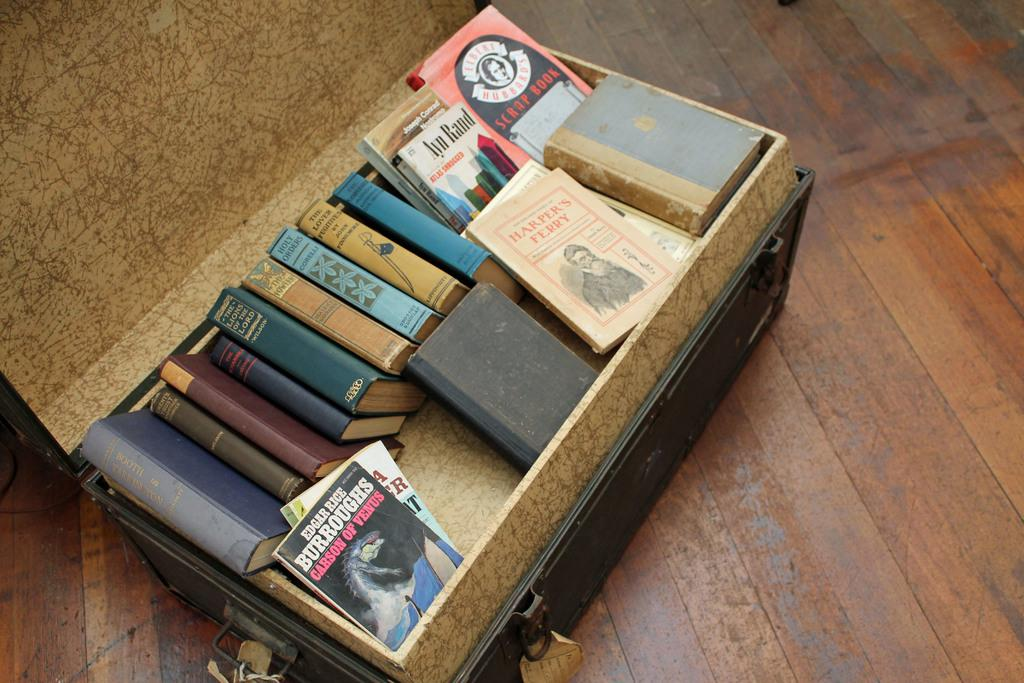<image>
Create a compact narrative representing the image presented. Collection of different Books in a chest, containing a book from Edgar Rice Carson of Venus. 